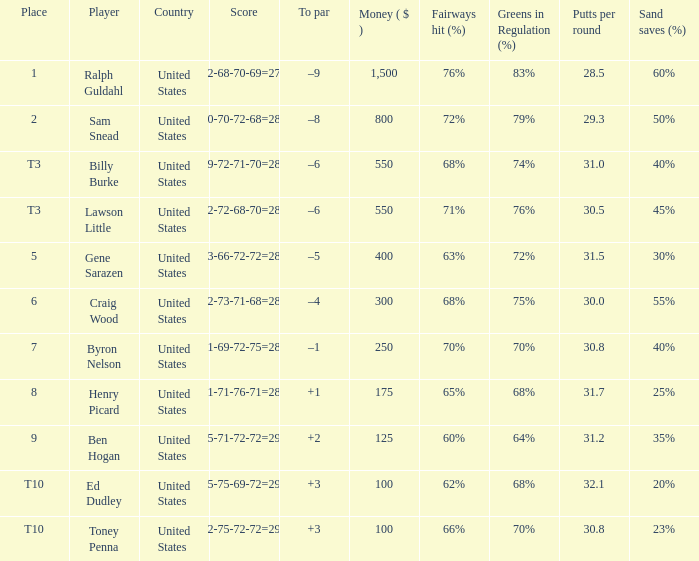Which to par has a prize less than $800? –8. 